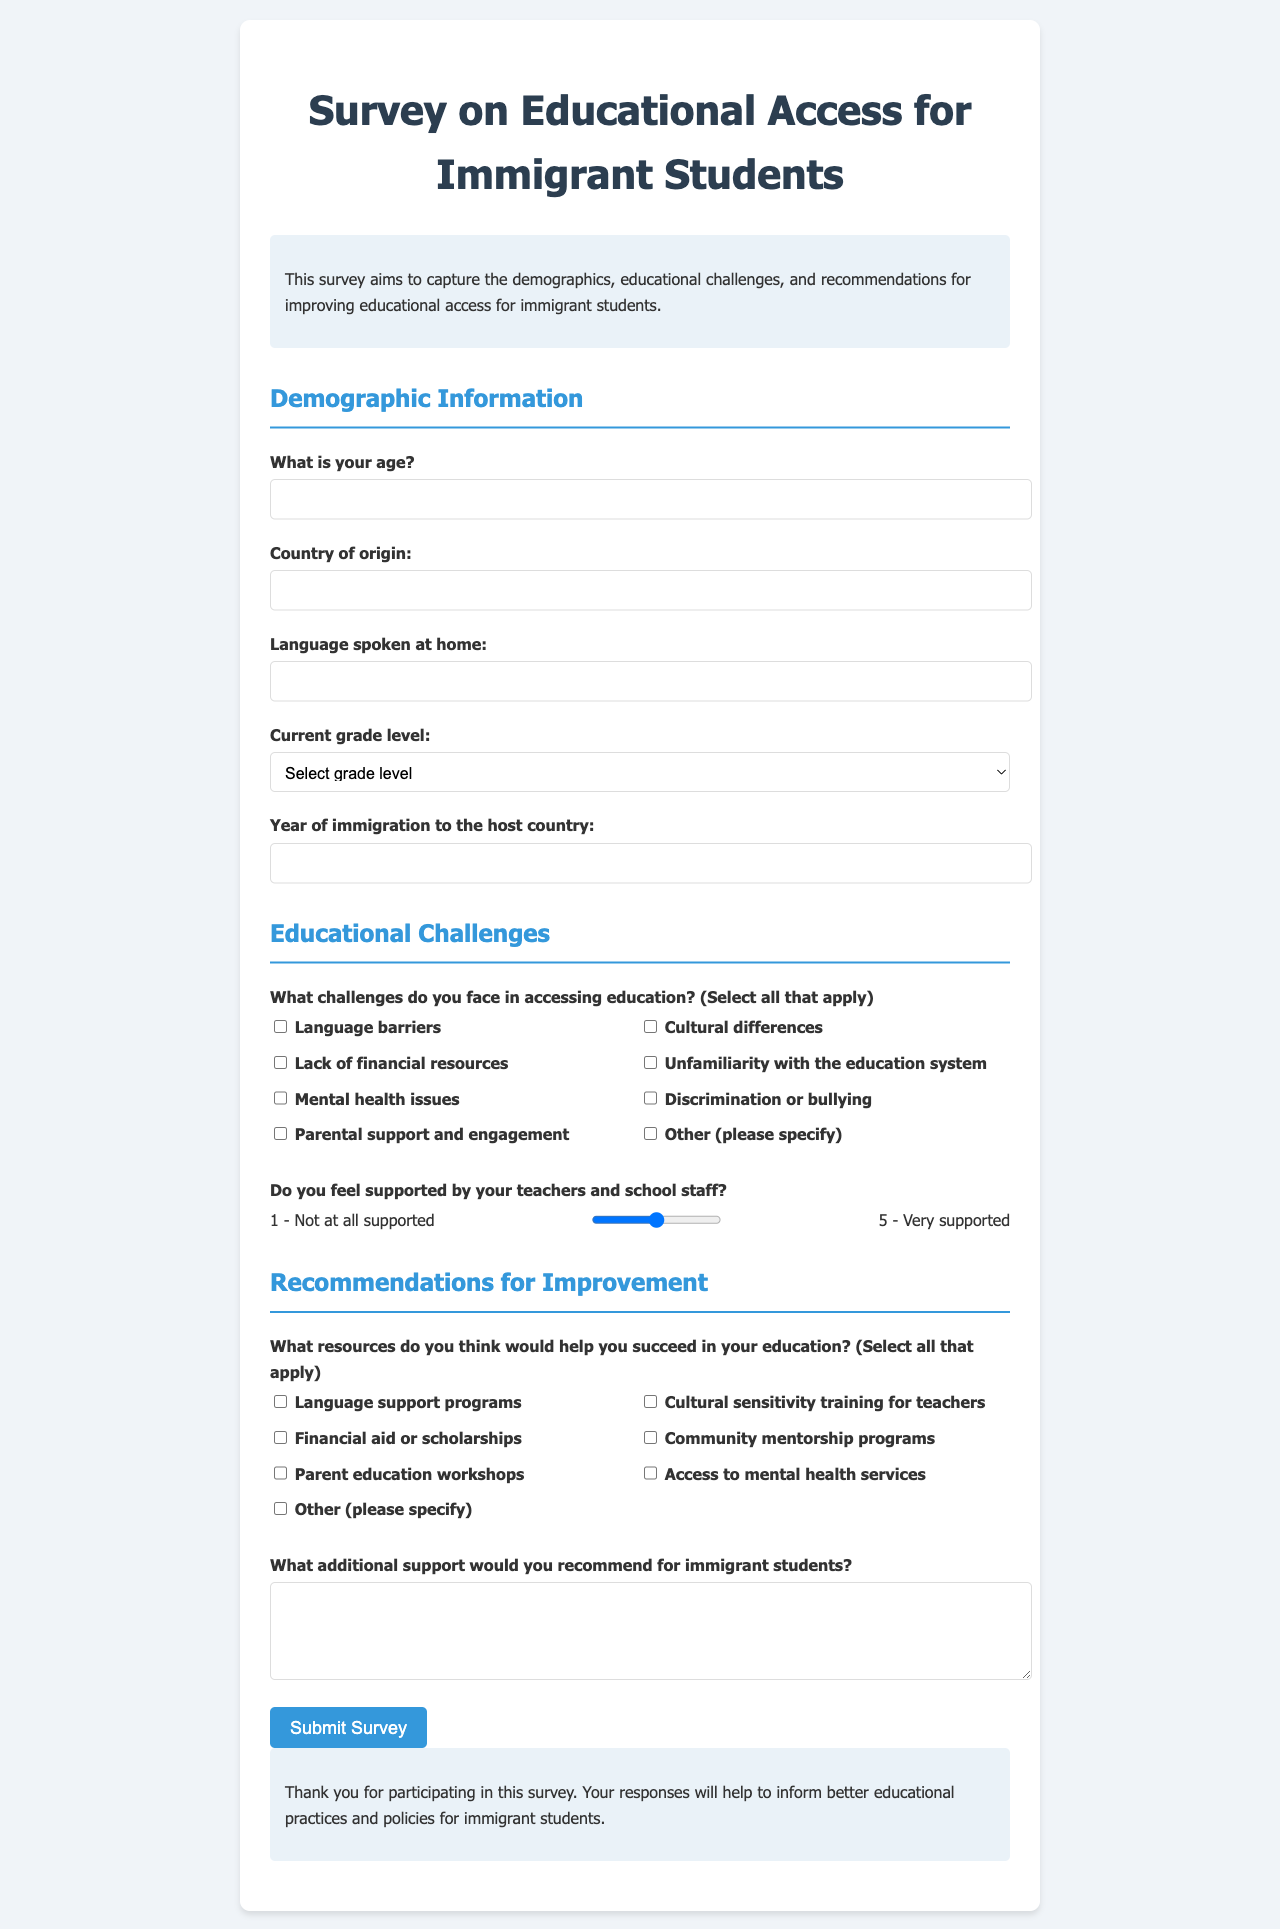What is the maximum age for survey participants? The document specifies a minimum age of 5 and a maximum age of 25 for survey participants.
Answer: 25 What country of origin should be specified? The survey asks for the participant's country of origin, indicating that this field is required.
Answer: Country of origin What grade levels can participants select from? The survey lists grade levels from Kindergarten through 12th Grade for selection.
Answer: Kindergarten to 12th Grade Which challenge is listed as a potential barrier to education? The document includes various challenges such as language barriers, cultural differences, and others that can affect educational access.
Answer: Language barriers What additional support is requested from the participants? The survey includes a section asking for recommendations on what other supports would help immigrant students succeed in their education.
Answer: Additional support What is the purpose of the survey? The document states that the survey aims to capture demographics, educational challenges, and recommendations for improving educational access for immigrant students.
Answer: Improve educational access How many range levels are provided to indicate support? The survey offers a scale from 1 to 5 for participants to indicate the level of support they feel from teachers and staff.
Answer: 5 What type of training is mentioned as a recommended resource? The document includes cultural sensitivity training for teachers as a suggested resource for immigrant students.
Answer: Cultural sensitivity training In what format do participants provide their recommendations? The document includes a textarea for participants to describe their recommendations for additional support.
Answer: Textarea What is the submission button labeled? The button used to submit the survey responses is labeled "Submit Survey".
Answer: Submit Survey 